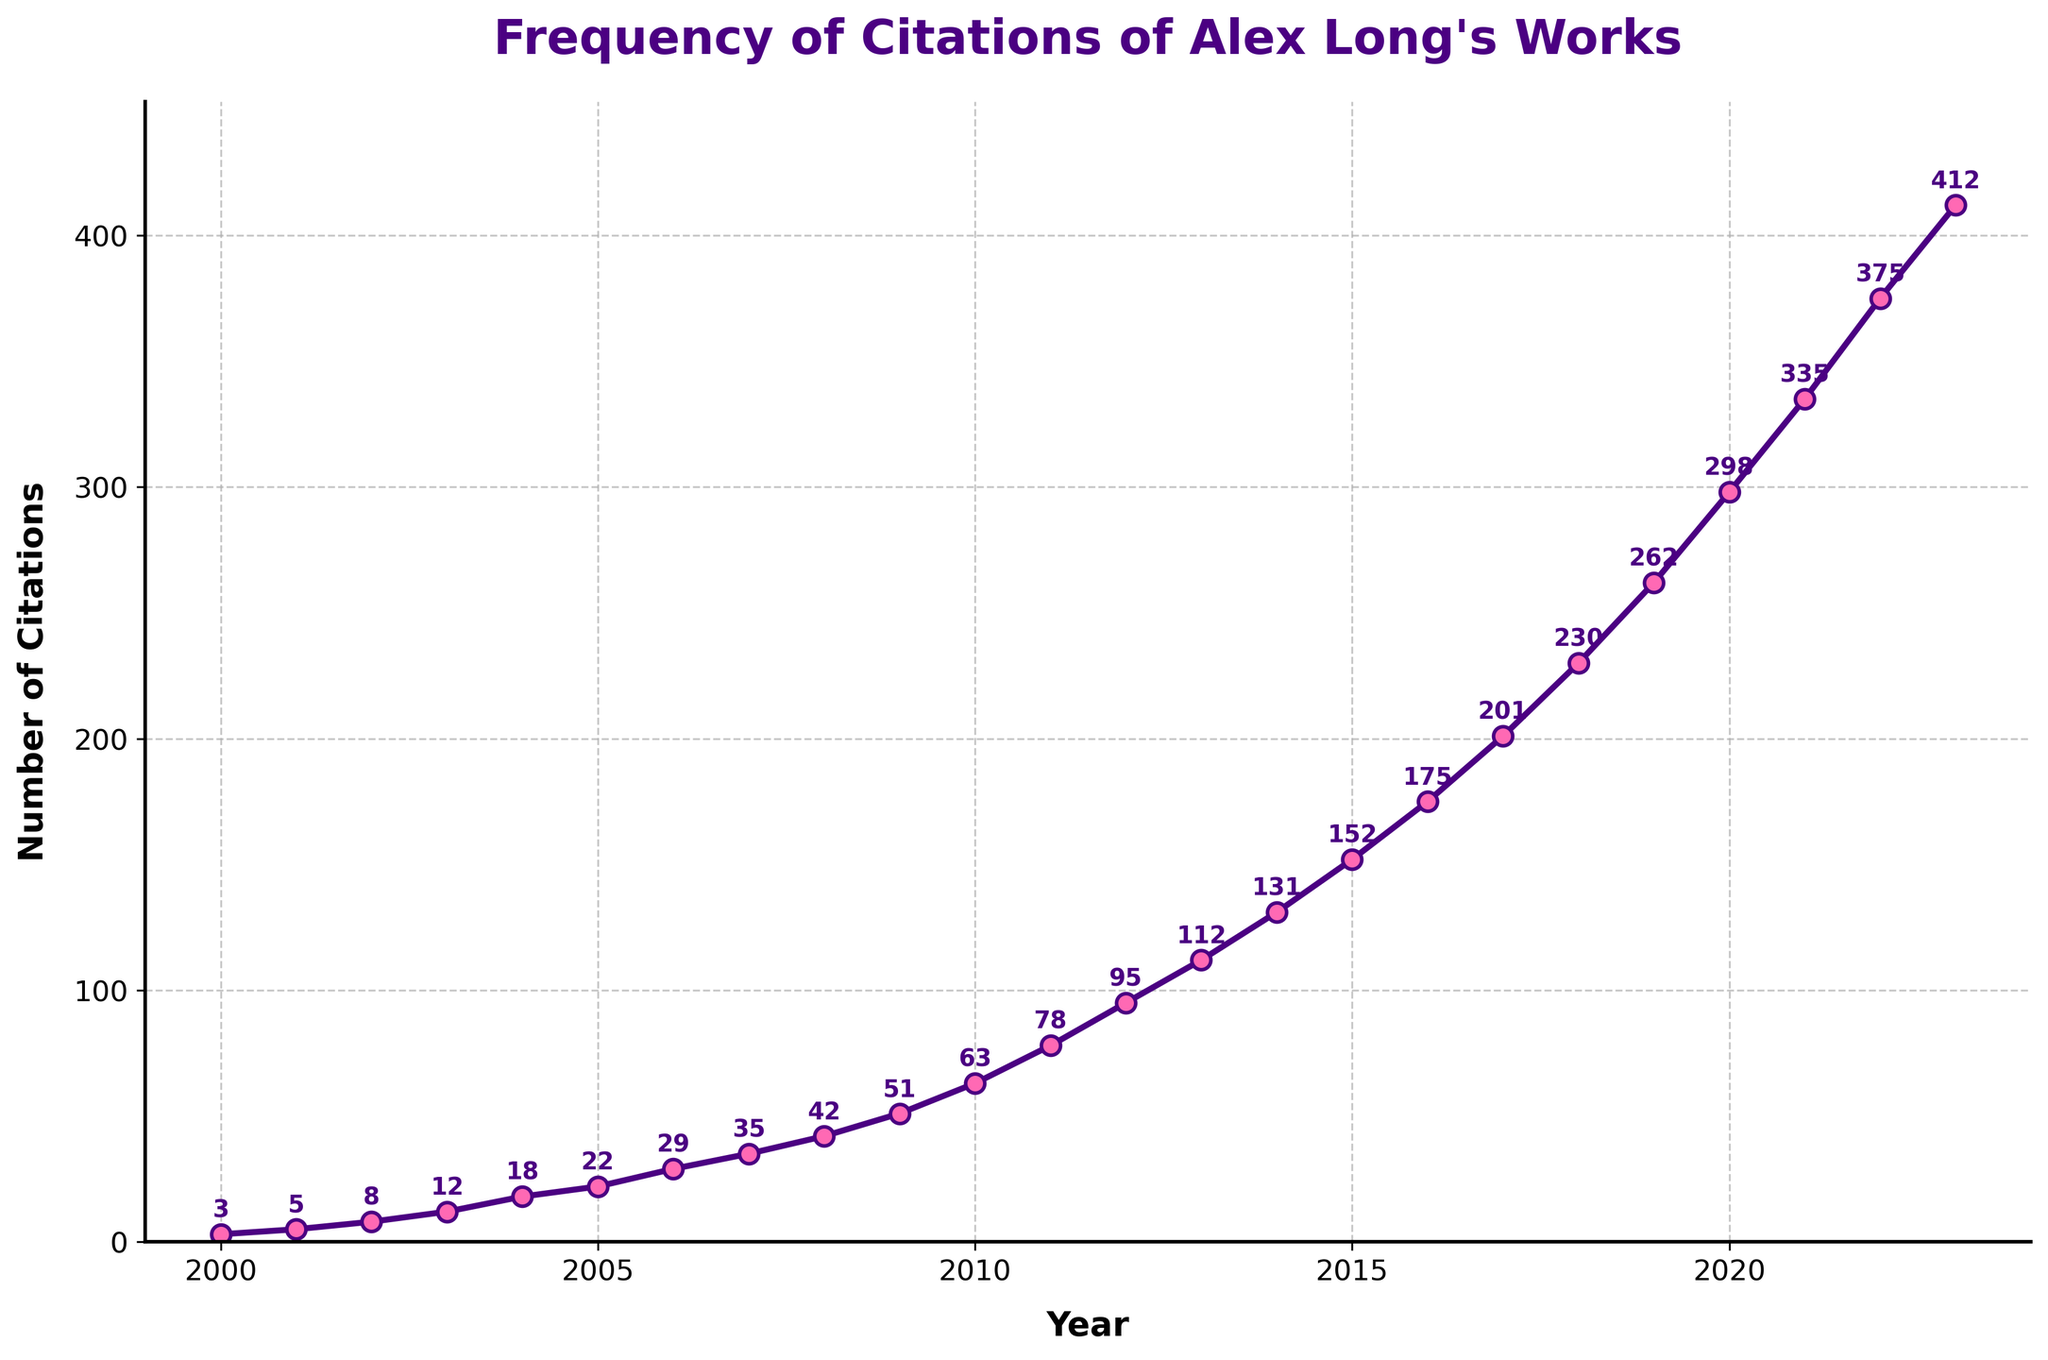What is the overall trend in the number of citations from 2000 to 2023? From 2000 to 2023, the number of citations of Alex Long's works shows a steady increase every year. The line graph slopes upward consistently, indicating growing recognition and citation frequency of his work over time.
Answer: Steady increase What is the difference in the number of citations between the years 2010 and 2020? In 2010, the number of citations was 63. By 2020, it had risen to 298. The difference can be found by subtracting the 2010 value from the 2020 value: 298 - 63 = 235.
Answer: 235 What is the average annual increase in citations between 2000 and 2023? First, find the total increase from 2000 to 2023, which is 412 - 3 = 409. There are 23 years between 2000 and 2023. The average annual increase is 409 / 23 ≈ 17.78.
Answer: 17.78 In which year did the number of citations cross 100? According to the data points on the graph, the number of citations crossed 100 in the year 2013 when it reached 112.
Answer: 2013 How many times did the number of citations increase by more than 30 from one year to the next? By examining the year-over-year changes, the years with more than a 30 citations increase are 2018 to 2019 (230 to 262, increase of 32), 2019 to 2020 (262 to 298, increase of 36), 2020 to 2021 (298 to 335, increase of 37), 2021 to 2022 (335 to 375, increase of 40), and 2022 to 2023 (375 to 412, increase of 37). This occurred 5 times.
Answer: 5 Which year saw the highest number of citations? Looking at the data points on the graph, the year 2023 saw the highest number of citations with 412.
Answer: 2023 What was the rate of increase in citations from 2015 to 2020? In 2015, there were 152 citations; in 2020, there were 298 citations. The increase is 298 - 152 = 146 over 5 years. The average rate of increase per year is 146 / 5 = 29.2.
Answer: 29.2 Identify the steepest slope segment in the graph and the corresponding years. The steepest slope occurs where the rate of increase is the highest. Comparing the segments visually, the steepest increase can be observed between 2021 (335 citations) and 2023 (412 citations). The change here is 412 - 335 = 77 over 2 years, which equals a 38.5 citations increase per year.
Answer: 2021-2023 